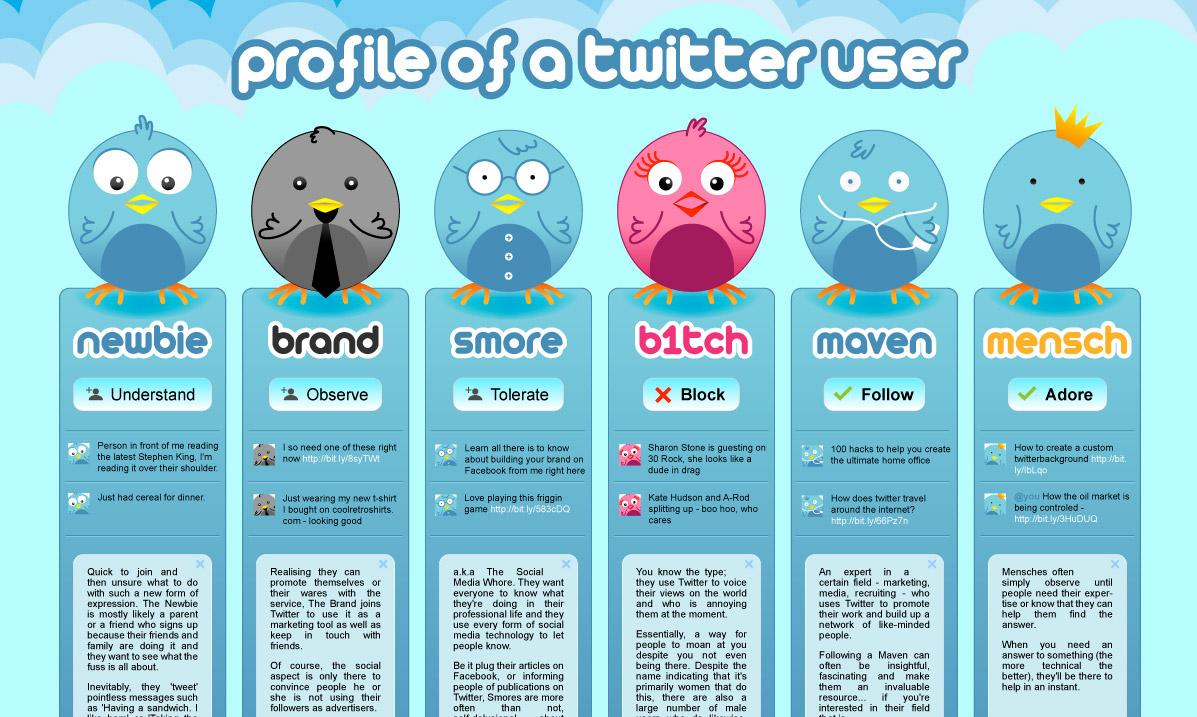Indicate a few pertinent items in this graphic. There are four birds with blue color in the given infographic. There are six options available in the profile of a Twitter user. 